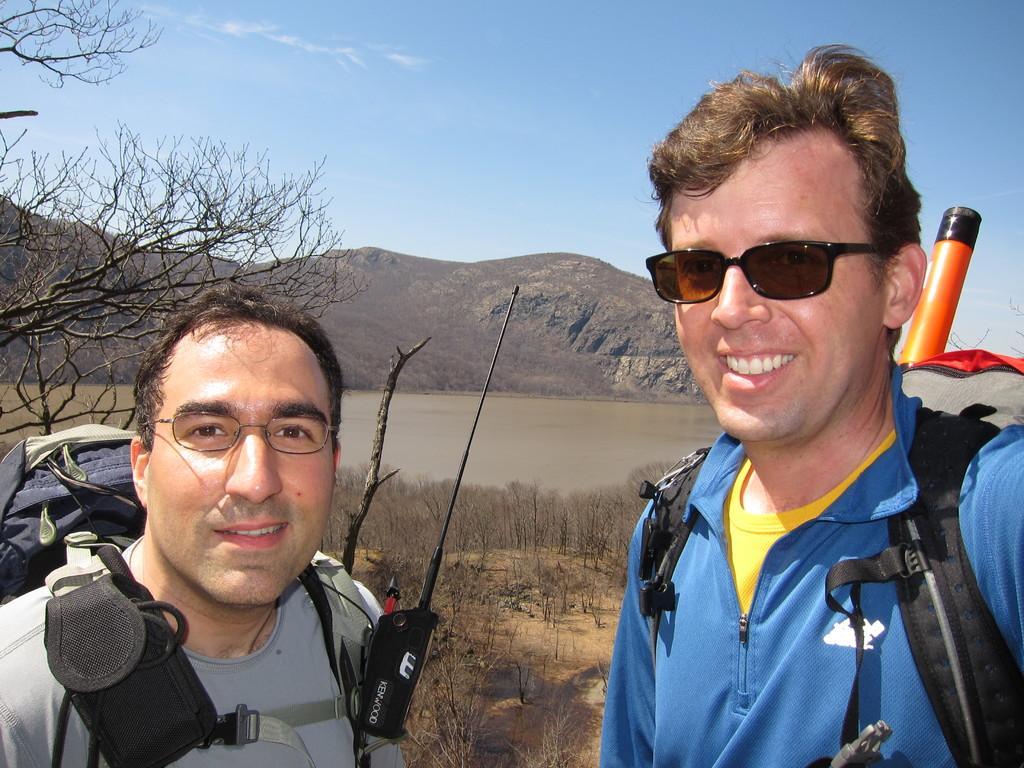Can you describe this image briefly? In the image there are two men in specs carrying bags and smiling, behind them there are dried trees on the land followed by a lake with a hill behind it and above its sky. 